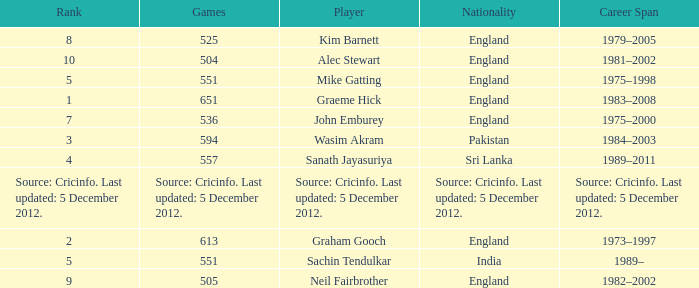What is the Nationality of Mike Gatting, who played 551 games? England. 